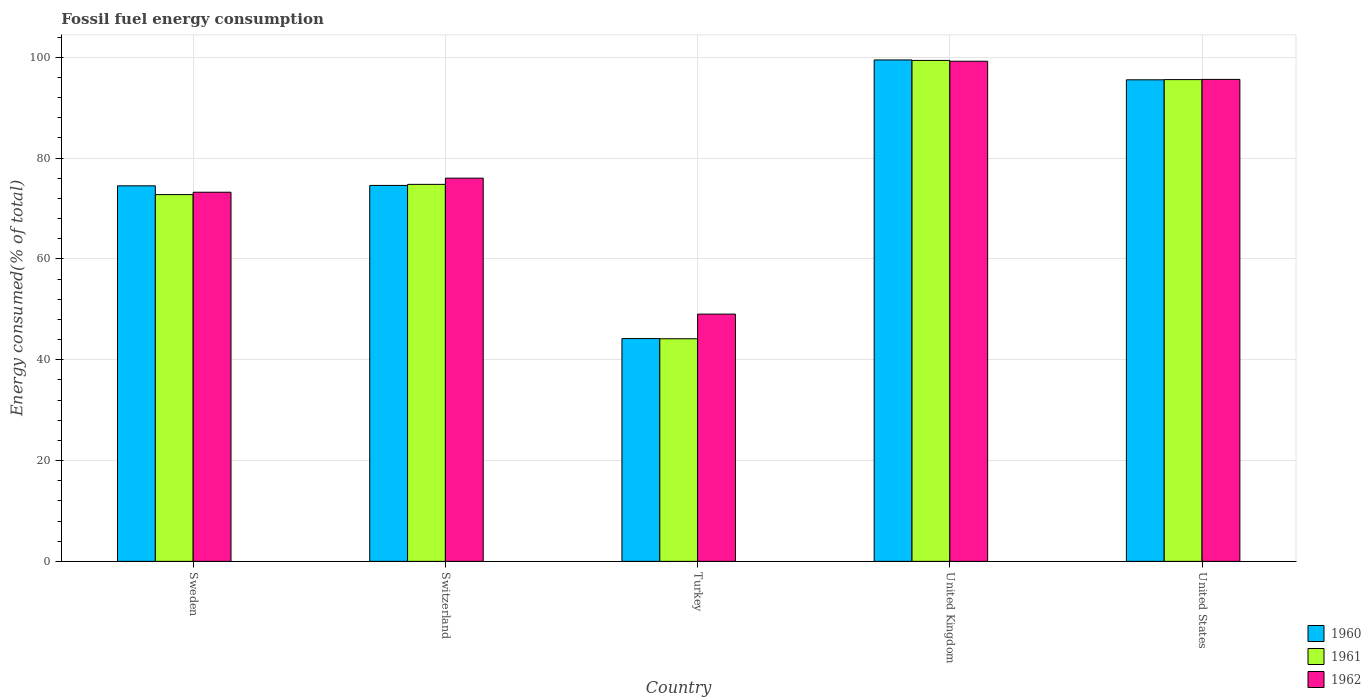How many different coloured bars are there?
Make the answer very short. 3. How many groups of bars are there?
Provide a succinct answer. 5. How many bars are there on the 4th tick from the left?
Offer a very short reply. 3. How many bars are there on the 5th tick from the right?
Keep it short and to the point. 3. What is the label of the 5th group of bars from the left?
Keep it short and to the point. United States. In how many cases, is the number of bars for a given country not equal to the number of legend labels?
Give a very brief answer. 0. What is the percentage of energy consumed in 1962 in United Kingdom?
Keep it short and to the point. 99.21. Across all countries, what is the maximum percentage of energy consumed in 1962?
Offer a terse response. 99.21. Across all countries, what is the minimum percentage of energy consumed in 1962?
Make the answer very short. 49.05. In which country was the percentage of energy consumed in 1962 minimum?
Provide a succinct answer. Turkey. What is the total percentage of energy consumed in 1962 in the graph?
Make the answer very short. 393.11. What is the difference between the percentage of energy consumed in 1960 in Switzerland and that in United Kingdom?
Your answer should be compact. -24.89. What is the difference between the percentage of energy consumed in 1962 in United Kingdom and the percentage of energy consumed in 1960 in Turkey?
Make the answer very short. 55.01. What is the average percentage of energy consumed in 1961 per country?
Offer a terse response. 77.33. What is the difference between the percentage of energy consumed of/in 1960 and percentage of energy consumed of/in 1961 in Sweden?
Offer a very short reply. 1.74. What is the ratio of the percentage of energy consumed in 1960 in Switzerland to that in United Kingdom?
Offer a very short reply. 0.75. Is the percentage of energy consumed in 1962 in Sweden less than that in Switzerland?
Make the answer very short. Yes. Is the difference between the percentage of energy consumed in 1960 in Turkey and United States greater than the difference between the percentage of energy consumed in 1961 in Turkey and United States?
Offer a very short reply. Yes. What is the difference between the highest and the second highest percentage of energy consumed in 1962?
Provide a succinct answer. 23.19. What is the difference between the highest and the lowest percentage of energy consumed in 1961?
Ensure brevity in your answer.  55.21. In how many countries, is the percentage of energy consumed in 1962 greater than the average percentage of energy consumed in 1962 taken over all countries?
Keep it short and to the point. 2. Is the sum of the percentage of energy consumed in 1962 in Turkey and United States greater than the maximum percentage of energy consumed in 1960 across all countries?
Give a very brief answer. Yes. What does the 3rd bar from the left in Turkey represents?
Keep it short and to the point. 1962. How many countries are there in the graph?
Offer a very short reply. 5. What is the difference between two consecutive major ticks on the Y-axis?
Provide a succinct answer. 20. Are the values on the major ticks of Y-axis written in scientific E-notation?
Your answer should be compact. No. How are the legend labels stacked?
Your answer should be very brief. Vertical. What is the title of the graph?
Provide a succinct answer. Fossil fuel energy consumption. Does "1968" appear as one of the legend labels in the graph?
Provide a short and direct response. No. What is the label or title of the X-axis?
Your answer should be very brief. Country. What is the label or title of the Y-axis?
Provide a short and direct response. Energy consumed(% of total). What is the Energy consumed(% of total) of 1960 in Sweden?
Keep it short and to the point. 74.49. What is the Energy consumed(% of total) in 1961 in Sweden?
Your response must be concise. 72.75. What is the Energy consumed(% of total) in 1962 in Sweden?
Your answer should be very brief. 73.23. What is the Energy consumed(% of total) of 1960 in Switzerland?
Keep it short and to the point. 74.57. What is the Energy consumed(% of total) of 1961 in Switzerland?
Ensure brevity in your answer.  74.78. What is the Energy consumed(% of total) in 1962 in Switzerland?
Keep it short and to the point. 76.02. What is the Energy consumed(% of total) in 1960 in Turkey?
Make the answer very short. 44.2. What is the Energy consumed(% of total) in 1961 in Turkey?
Your answer should be very brief. 44.16. What is the Energy consumed(% of total) in 1962 in Turkey?
Give a very brief answer. 49.05. What is the Energy consumed(% of total) in 1960 in United Kingdom?
Your answer should be compact. 99.46. What is the Energy consumed(% of total) in 1961 in United Kingdom?
Your response must be concise. 99.37. What is the Energy consumed(% of total) in 1962 in United Kingdom?
Give a very brief answer. 99.21. What is the Energy consumed(% of total) in 1960 in United States?
Your response must be concise. 95.53. What is the Energy consumed(% of total) of 1961 in United States?
Offer a terse response. 95.57. What is the Energy consumed(% of total) of 1962 in United States?
Make the answer very short. 95.61. Across all countries, what is the maximum Energy consumed(% of total) in 1960?
Your response must be concise. 99.46. Across all countries, what is the maximum Energy consumed(% of total) of 1961?
Offer a very short reply. 99.37. Across all countries, what is the maximum Energy consumed(% of total) in 1962?
Provide a short and direct response. 99.21. Across all countries, what is the minimum Energy consumed(% of total) of 1960?
Your response must be concise. 44.2. Across all countries, what is the minimum Energy consumed(% of total) in 1961?
Your answer should be compact. 44.16. Across all countries, what is the minimum Energy consumed(% of total) of 1962?
Your answer should be very brief. 49.05. What is the total Energy consumed(% of total) of 1960 in the graph?
Ensure brevity in your answer.  388.25. What is the total Energy consumed(% of total) of 1961 in the graph?
Offer a very short reply. 386.63. What is the total Energy consumed(% of total) in 1962 in the graph?
Offer a very short reply. 393.11. What is the difference between the Energy consumed(% of total) in 1960 in Sweden and that in Switzerland?
Provide a short and direct response. -0.08. What is the difference between the Energy consumed(% of total) of 1961 in Sweden and that in Switzerland?
Your answer should be compact. -2.03. What is the difference between the Energy consumed(% of total) of 1962 in Sweden and that in Switzerland?
Keep it short and to the point. -2.79. What is the difference between the Energy consumed(% of total) of 1960 in Sweden and that in Turkey?
Make the answer very short. 30.29. What is the difference between the Energy consumed(% of total) in 1961 in Sweden and that in Turkey?
Keep it short and to the point. 28.59. What is the difference between the Energy consumed(% of total) of 1962 in Sweden and that in Turkey?
Your answer should be compact. 24.18. What is the difference between the Energy consumed(% of total) in 1960 in Sweden and that in United Kingdom?
Keep it short and to the point. -24.97. What is the difference between the Energy consumed(% of total) in 1961 in Sweden and that in United Kingdom?
Give a very brief answer. -26.61. What is the difference between the Energy consumed(% of total) in 1962 in Sweden and that in United Kingdom?
Make the answer very short. -25.98. What is the difference between the Energy consumed(% of total) in 1960 in Sweden and that in United States?
Offer a terse response. -21.03. What is the difference between the Energy consumed(% of total) of 1961 in Sweden and that in United States?
Your answer should be very brief. -22.81. What is the difference between the Energy consumed(% of total) in 1962 in Sweden and that in United States?
Provide a succinct answer. -22.38. What is the difference between the Energy consumed(% of total) of 1960 in Switzerland and that in Turkey?
Provide a succinct answer. 30.37. What is the difference between the Energy consumed(% of total) of 1961 in Switzerland and that in Turkey?
Offer a terse response. 30.62. What is the difference between the Energy consumed(% of total) in 1962 in Switzerland and that in Turkey?
Keep it short and to the point. 26.97. What is the difference between the Energy consumed(% of total) of 1960 in Switzerland and that in United Kingdom?
Ensure brevity in your answer.  -24.89. What is the difference between the Energy consumed(% of total) of 1961 in Switzerland and that in United Kingdom?
Offer a terse response. -24.58. What is the difference between the Energy consumed(% of total) of 1962 in Switzerland and that in United Kingdom?
Keep it short and to the point. -23.19. What is the difference between the Energy consumed(% of total) in 1960 in Switzerland and that in United States?
Your answer should be compact. -20.95. What is the difference between the Energy consumed(% of total) in 1961 in Switzerland and that in United States?
Offer a very short reply. -20.78. What is the difference between the Energy consumed(% of total) in 1962 in Switzerland and that in United States?
Your response must be concise. -19.59. What is the difference between the Energy consumed(% of total) in 1960 in Turkey and that in United Kingdom?
Your answer should be compact. -55.27. What is the difference between the Energy consumed(% of total) of 1961 in Turkey and that in United Kingdom?
Your answer should be compact. -55.21. What is the difference between the Energy consumed(% of total) of 1962 in Turkey and that in United Kingdom?
Keep it short and to the point. -50.16. What is the difference between the Energy consumed(% of total) in 1960 in Turkey and that in United States?
Keep it short and to the point. -51.33. What is the difference between the Energy consumed(% of total) of 1961 in Turkey and that in United States?
Give a very brief answer. -51.41. What is the difference between the Energy consumed(% of total) in 1962 in Turkey and that in United States?
Your answer should be compact. -46.56. What is the difference between the Energy consumed(% of total) of 1960 in United Kingdom and that in United States?
Keep it short and to the point. 3.94. What is the difference between the Energy consumed(% of total) of 1961 in United Kingdom and that in United States?
Your answer should be very brief. 3.8. What is the difference between the Energy consumed(% of total) in 1962 in United Kingdom and that in United States?
Your answer should be very brief. 3.6. What is the difference between the Energy consumed(% of total) in 1960 in Sweden and the Energy consumed(% of total) in 1961 in Switzerland?
Give a very brief answer. -0.29. What is the difference between the Energy consumed(% of total) of 1960 in Sweden and the Energy consumed(% of total) of 1962 in Switzerland?
Make the answer very short. -1.52. What is the difference between the Energy consumed(% of total) of 1961 in Sweden and the Energy consumed(% of total) of 1962 in Switzerland?
Your answer should be compact. -3.26. What is the difference between the Energy consumed(% of total) of 1960 in Sweden and the Energy consumed(% of total) of 1961 in Turkey?
Keep it short and to the point. 30.33. What is the difference between the Energy consumed(% of total) in 1960 in Sweden and the Energy consumed(% of total) in 1962 in Turkey?
Provide a short and direct response. 25.44. What is the difference between the Energy consumed(% of total) in 1961 in Sweden and the Energy consumed(% of total) in 1962 in Turkey?
Ensure brevity in your answer.  23.7. What is the difference between the Energy consumed(% of total) in 1960 in Sweden and the Energy consumed(% of total) in 1961 in United Kingdom?
Offer a very short reply. -24.87. What is the difference between the Energy consumed(% of total) of 1960 in Sweden and the Energy consumed(% of total) of 1962 in United Kingdom?
Provide a short and direct response. -24.71. What is the difference between the Energy consumed(% of total) in 1961 in Sweden and the Energy consumed(% of total) in 1962 in United Kingdom?
Your answer should be compact. -26.45. What is the difference between the Energy consumed(% of total) in 1960 in Sweden and the Energy consumed(% of total) in 1961 in United States?
Give a very brief answer. -21.07. What is the difference between the Energy consumed(% of total) in 1960 in Sweden and the Energy consumed(% of total) in 1962 in United States?
Offer a terse response. -21.11. What is the difference between the Energy consumed(% of total) in 1961 in Sweden and the Energy consumed(% of total) in 1962 in United States?
Keep it short and to the point. -22.85. What is the difference between the Energy consumed(% of total) in 1960 in Switzerland and the Energy consumed(% of total) in 1961 in Turkey?
Ensure brevity in your answer.  30.41. What is the difference between the Energy consumed(% of total) in 1960 in Switzerland and the Energy consumed(% of total) in 1962 in Turkey?
Your answer should be compact. 25.52. What is the difference between the Energy consumed(% of total) in 1961 in Switzerland and the Energy consumed(% of total) in 1962 in Turkey?
Offer a terse response. 25.73. What is the difference between the Energy consumed(% of total) of 1960 in Switzerland and the Energy consumed(% of total) of 1961 in United Kingdom?
Provide a short and direct response. -24.8. What is the difference between the Energy consumed(% of total) in 1960 in Switzerland and the Energy consumed(% of total) in 1962 in United Kingdom?
Give a very brief answer. -24.64. What is the difference between the Energy consumed(% of total) in 1961 in Switzerland and the Energy consumed(% of total) in 1962 in United Kingdom?
Offer a very short reply. -24.42. What is the difference between the Energy consumed(% of total) of 1960 in Switzerland and the Energy consumed(% of total) of 1961 in United States?
Ensure brevity in your answer.  -20.99. What is the difference between the Energy consumed(% of total) of 1960 in Switzerland and the Energy consumed(% of total) of 1962 in United States?
Ensure brevity in your answer.  -21.03. What is the difference between the Energy consumed(% of total) in 1961 in Switzerland and the Energy consumed(% of total) in 1962 in United States?
Your response must be concise. -20.82. What is the difference between the Energy consumed(% of total) of 1960 in Turkey and the Energy consumed(% of total) of 1961 in United Kingdom?
Your response must be concise. -55.17. What is the difference between the Energy consumed(% of total) in 1960 in Turkey and the Energy consumed(% of total) in 1962 in United Kingdom?
Provide a short and direct response. -55.01. What is the difference between the Energy consumed(% of total) in 1961 in Turkey and the Energy consumed(% of total) in 1962 in United Kingdom?
Your answer should be very brief. -55.05. What is the difference between the Energy consumed(% of total) of 1960 in Turkey and the Energy consumed(% of total) of 1961 in United States?
Make the answer very short. -51.37. What is the difference between the Energy consumed(% of total) of 1960 in Turkey and the Energy consumed(% of total) of 1962 in United States?
Give a very brief answer. -51.41. What is the difference between the Energy consumed(% of total) in 1961 in Turkey and the Energy consumed(% of total) in 1962 in United States?
Give a very brief answer. -51.45. What is the difference between the Energy consumed(% of total) in 1960 in United Kingdom and the Energy consumed(% of total) in 1961 in United States?
Provide a succinct answer. 3.9. What is the difference between the Energy consumed(% of total) in 1960 in United Kingdom and the Energy consumed(% of total) in 1962 in United States?
Offer a terse response. 3.86. What is the difference between the Energy consumed(% of total) of 1961 in United Kingdom and the Energy consumed(% of total) of 1962 in United States?
Provide a succinct answer. 3.76. What is the average Energy consumed(% of total) of 1960 per country?
Offer a very short reply. 77.65. What is the average Energy consumed(% of total) in 1961 per country?
Your answer should be very brief. 77.33. What is the average Energy consumed(% of total) of 1962 per country?
Offer a very short reply. 78.62. What is the difference between the Energy consumed(% of total) of 1960 and Energy consumed(% of total) of 1961 in Sweden?
Your answer should be very brief. 1.74. What is the difference between the Energy consumed(% of total) in 1960 and Energy consumed(% of total) in 1962 in Sweden?
Your answer should be very brief. 1.27. What is the difference between the Energy consumed(% of total) of 1961 and Energy consumed(% of total) of 1962 in Sweden?
Your response must be concise. -0.47. What is the difference between the Energy consumed(% of total) of 1960 and Energy consumed(% of total) of 1961 in Switzerland?
Offer a terse response. -0.21. What is the difference between the Energy consumed(% of total) of 1960 and Energy consumed(% of total) of 1962 in Switzerland?
Provide a succinct answer. -1.45. What is the difference between the Energy consumed(% of total) of 1961 and Energy consumed(% of total) of 1962 in Switzerland?
Offer a very short reply. -1.23. What is the difference between the Energy consumed(% of total) of 1960 and Energy consumed(% of total) of 1962 in Turkey?
Provide a short and direct response. -4.85. What is the difference between the Energy consumed(% of total) of 1961 and Energy consumed(% of total) of 1962 in Turkey?
Provide a short and direct response. -4.89. What is the difference between the Energy consumed(% of total) in 1960 and Energy consumed(% of total) in 1961 in United Kingdom?
Provide a succinct answer. 0.1. What is the difference between the Energy consumed(% of total) of 1960 and Energy consumed(% of total) of 1962 in United Kingdom?
Offer a terse response. 0.26. What is the difference between the Energy consumed(% of total) of 1961 and Energy consumed(% of total) of 1962 in United Kingdom?
Give a very brief answer. 0.16. What is the difference between the Energy consumed(% of total) of 1960 and Energy consumed(% of total) of 1961 in United States?
Your response must be concise. -0.04. What is the difference between the Energy consumed(% of total) of 1960 and Energy consumed(% of total) of 1962 in United States?
Your answer should be compact. -0.08. What is the difference between the Energy consumed(% of total) in 1961 and Energy consumed(% of total) in 1962 in United States?
Offer a terse response. -0.04. What is the ratio of the Energy consumed(% of total) in 1960 in Sweden to that in Switzerland?
Offer a terse response. 1. What is the ratio of the Energy consumed(% of total) of 1961 in Sweden to that in Switzerland?
Make the answer very short. 0.97. What is the ratio of the Energy consumed(% of total) in 1962 in Sweden to that in Switzerland?
Your answer should be compact. 0.96. What is the ratio of the Energy consumed(% of total) of 1960 in Sweden to that in Turkey?
Your answer should be very brief. 1.69. What is the ratio of the Energy consumed(% of total) of 1961 in Sweden to that in Turkey?
Give a very brief answer. 1.65. What is the ratio of the Energy consumed(% of total) in 1962 in Sweden to that in Turkey?
Your answer should be compact. 1.49. What is the ratio of the Energy consumed(% of total) of 1960 in Sweden to that in United Kingdom?
Provide a succinct answer. 0.75. What is the ratio of the Energy consumed(% of total) in 1961 in Sweden to that in United Kingdom?
Provide a short and direct response. 0.73. What is the ratio of the Energy consumed(% of total) in 1962 in Sweden to that in United Kingdom?
Keep it short and to the point. 0.74. What is the ratio of the Energy consumed(% of total) in 1960 in Sweden to that in United States?
Offer a terse response. 0.78. What is the ratio of the Energy consumed(% of total) in 1961 in Sweden to that in United States?
Your response must be concise. 0.76. What is the ratio of the Energy consumed(% of total) in 1962 in Sweden to that in United States?
Your answer should be compact. 0.77. What is the ratio of the Energy consumed(% of total) of 1960 in Switzerland to that in Turkey?
Your answer should be very brief. 1.69. What is the ratio of the Energy consumed(% of total) in 1961 in Switzerland to that in Turkey?
Offer a very short reply. 1.69. What is the ratio of the Energy consumed(% of total) in 1962 in Switzerland to that in Turkey?
Provide a short and direct response. 1.55. What is the ratio of the Energy consumed(% of total) in 1960 in Switzerland to that in United Kingdom?
Keep it short and to the point. 0.75. What is the ratio of the Energy consumed(% of total) of 1961 in Switzerland to that in United Kingdom?
Make the answer very short. 0.75. What is the ratio of the Energy consumed(% of total) of 1962 in Switzerland to that in United Kingdom?
Offer a terse response. 0.77. What is the ratio of the Energy consumed(% of total) of 1960 in Switzerland to that in United States?
Your response must be concise. 0.78. What is the ratio of the Energy consumed(% of total) in 1961 in Switzerland to that in United States?
Your answer should be very brief. 0.78. What is the ratio of the Energy consumed(% of total) in 1962 in Switzerland to that in United States?
Offer a terse response. 0.8. What is the ratio of the Energy consumed(% of total) of 1960 in Turkey to that in United Kingdom?
Your answer should be compact. 0.44. What is the ratio of the Energy consumed(% of total) of 1961 in Turkey to that in United Kingdom?
Ensure brevity in your answer.  0.44. What is the ratio of the Energy consumed(% of total) of 1962 in Turkey to that in United Kingdom?
Provide a short and direct response. 0.49. What is the ratio of the Energy consumed(% of total) of 1960 in Turkey to that in United States?
Provide a short and direct response. 0.46. What is the ratio of the Energy consumed(% of total) of 1961 in Turkey to that in United States?
Your response must be concise. 0.46. What is the ratio of the Energy consumed(% of total) in 1962 in Turkey to that in United States?
Your response must be concise. 0.51. What is the ratio of the Energy consumed(% of total) in 1960 in United Kingdom to that in United States?
Provide a succinct answer. 1.04. What is the ratio of the Energy consumed(% of total) of 1961 in United Kingdom to that in United States?
Provide a succinct answer. 1.04. What is the ratio of the Energy consumed(% of total) of 1962 in United Kingdom to that in United States?
Give a very brief answer. 1.04. What is the difference between the highest and the second highest Energy consumed(% of total) in 1960?
Keep it short and to the point. 3.94. What is the difference between the highest and the second highest Energy consumed(% of total) of 1961?
Offer a terse response. 3.8. What is the difference between the highest and the second highest Energy consumed(% of total) of 1962?
Your answer should be compact. 3.6. What is the difference between the highest and the lowest Energy consumed(% of total) of 1960?
Ensure brevity in your answer.  55.27. What is the difference between the highest and the lowest Energy consumed(% of total) in 1961?
Offer a very short reply. 55.21. What is the difference between the highest and the lowest Energy consumed(% of total) of 1962?
Make the answer very short. 50.16. 